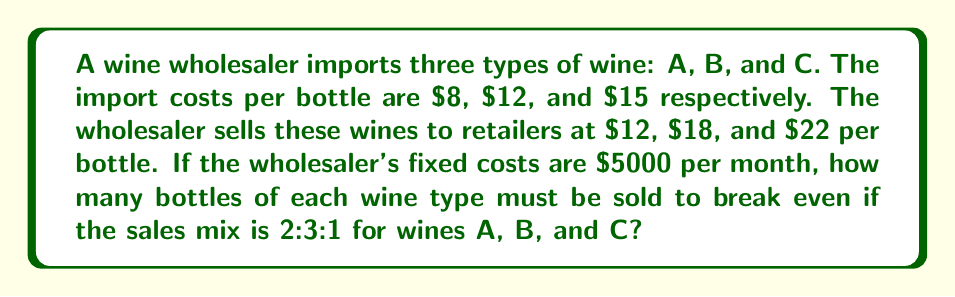Can you solve this math problem? Let's approach this step-by-step:

1) First, let's calculate the profit margin for each wine type:
   Wine A: $12 - $8 = $4 profit per bottle
   Wine B: $18 - $12 = $6 profit per bottle
   Wine C: $22 - $15 = $7 profit per bottle

2) Now, let's define our variables:
   Let x be the number of units of Wine A sold
   Then, 1.5x will be the number of units of Wine B sold (3:2 ratio)
   And 0.5x will be the number of units of Wine C sold (1:2 ratio)

3) We can now set up our break-even equation:
   Total Revenue - Total Cost = Fixed Cost
   $$(12x + 18(1.5x) + 22(0.5x)) - (8x + 12(1.5x) + 15(0.5x)) = 5000$$

4) Simplify the equation:
   $$(12x + 27x + 11x) - (8x + 18x + 7.5x) = 5000$$
   $$50x - 33.5x = 5000$$
   $$16.5x = 5000$$

5) Solve for x:
   $$x = \frac{5000}{16.5} \approx 303.03$$

6) Since we can't sell partial bottles, we round up to 304 bottles of Wine A.

7) Calculate the number of bottles for Wines B and C:
   Wine B: 1.5 * 304 = 456 bottles
   Wine C: 0.5 * 304 = 152 bottles
Answer: 304 bottles of Wine A, 456 bottles of Wine B, and 152 bottles of Wine C 